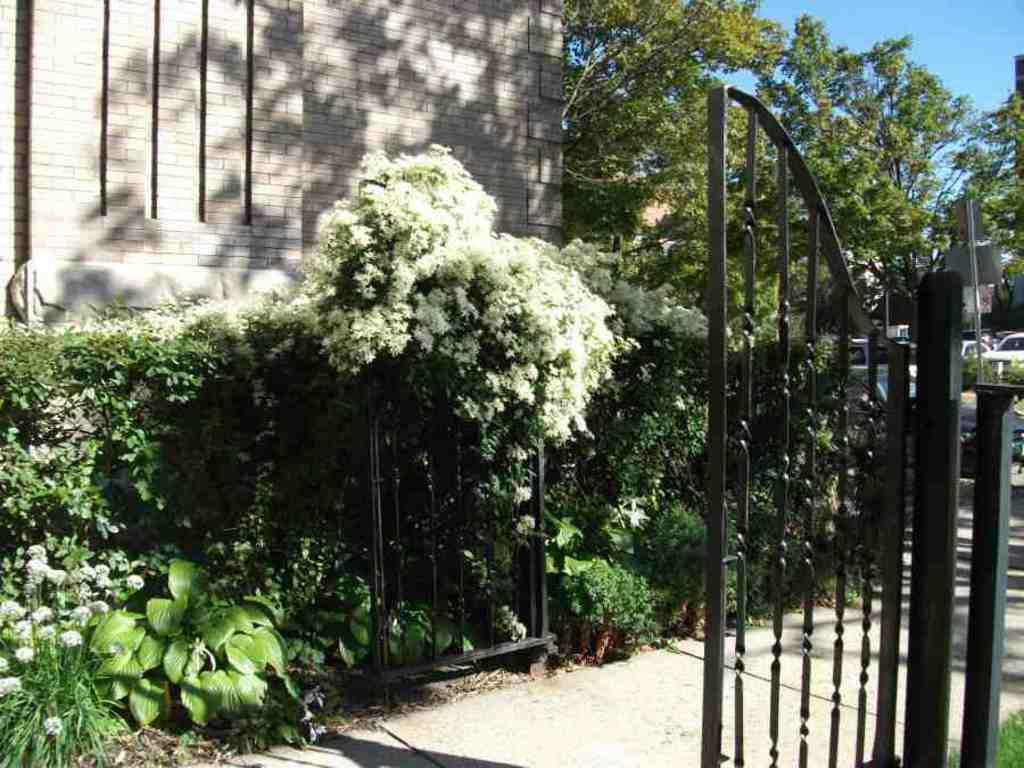What type of structure can be seen in the image? There is an iron gate in the image. What is located on one side of the gate? Trees are present on one side of the gate. What is located on the other side of the gate? Plants are present on the other side of the gate. Who is the father of the invention depicted in the image? There is no invention depicted in the image, so it is not possible to determine who the father of the invention might be. 